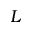<formula> <loc_0><loc_0><loc_500><loc_500>L</formula> 